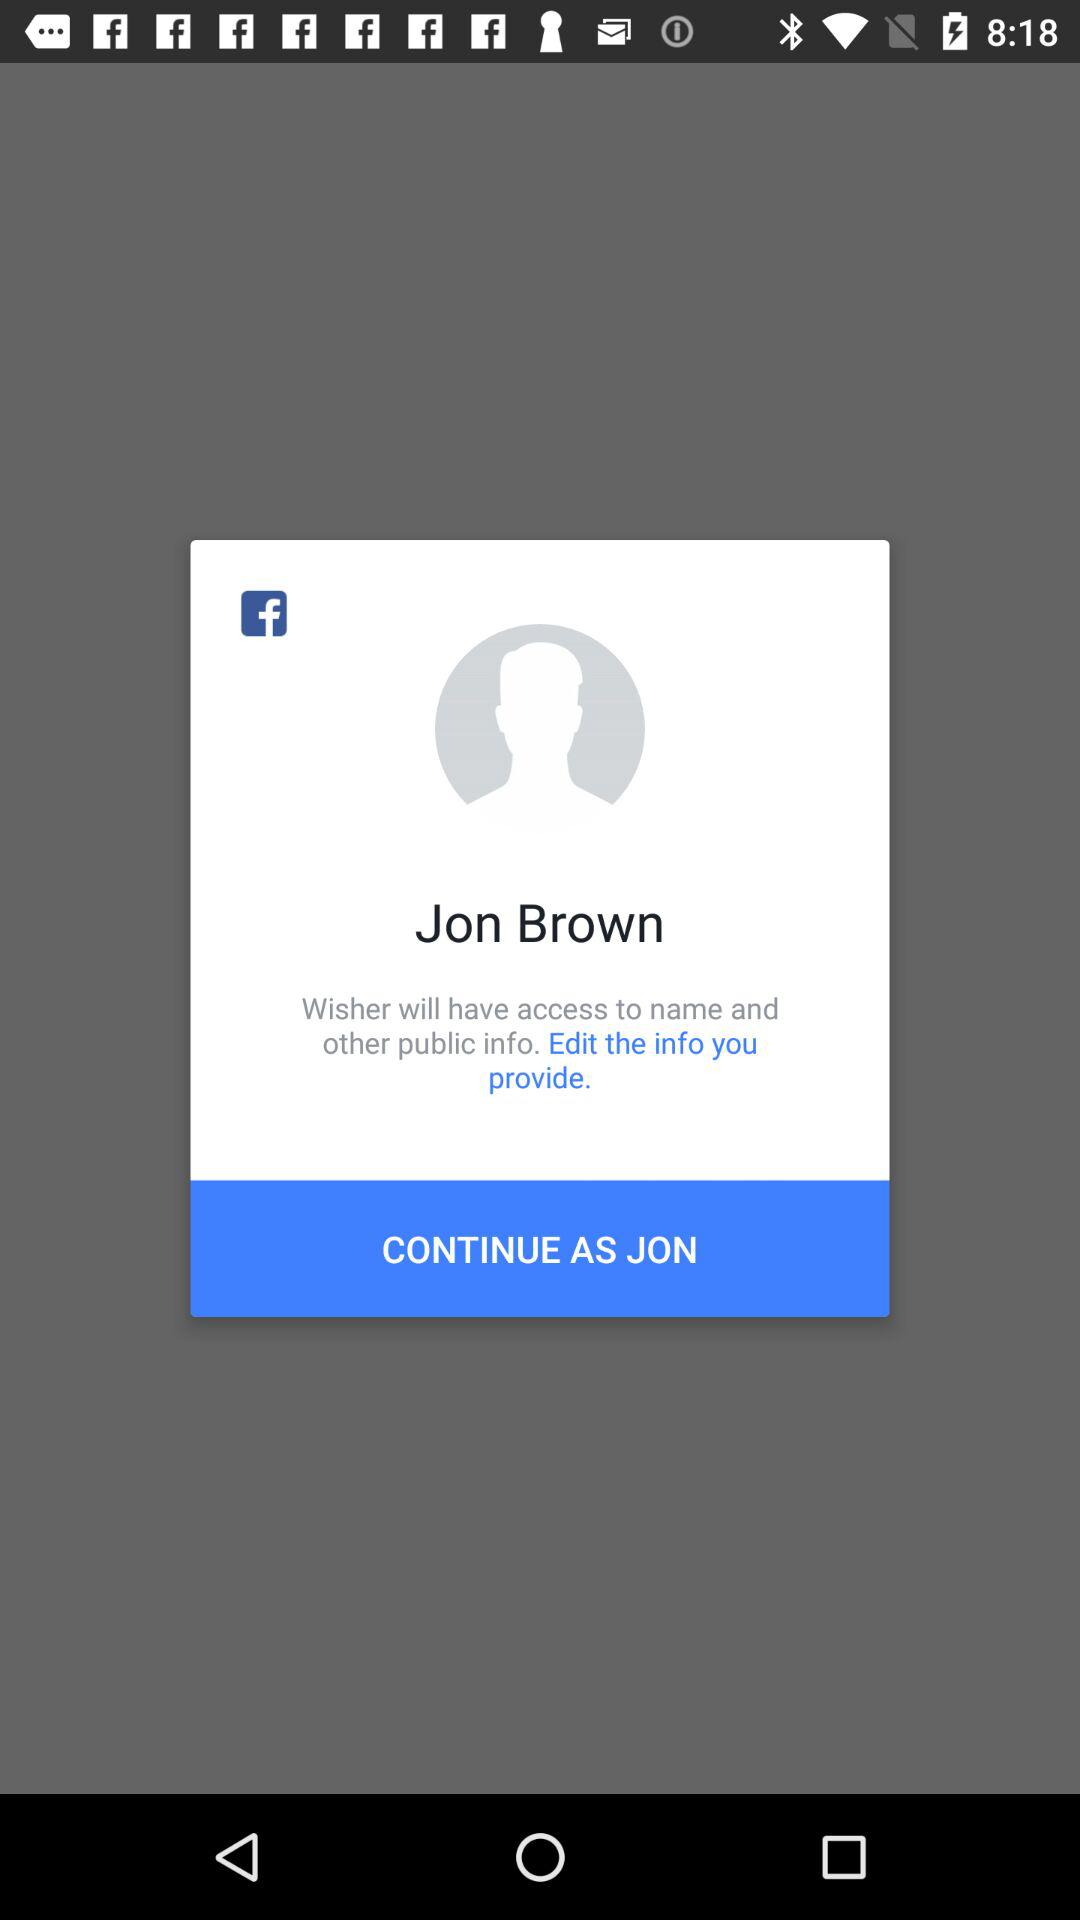What application is asking for permission? The application asking for permission is "Wisher". 